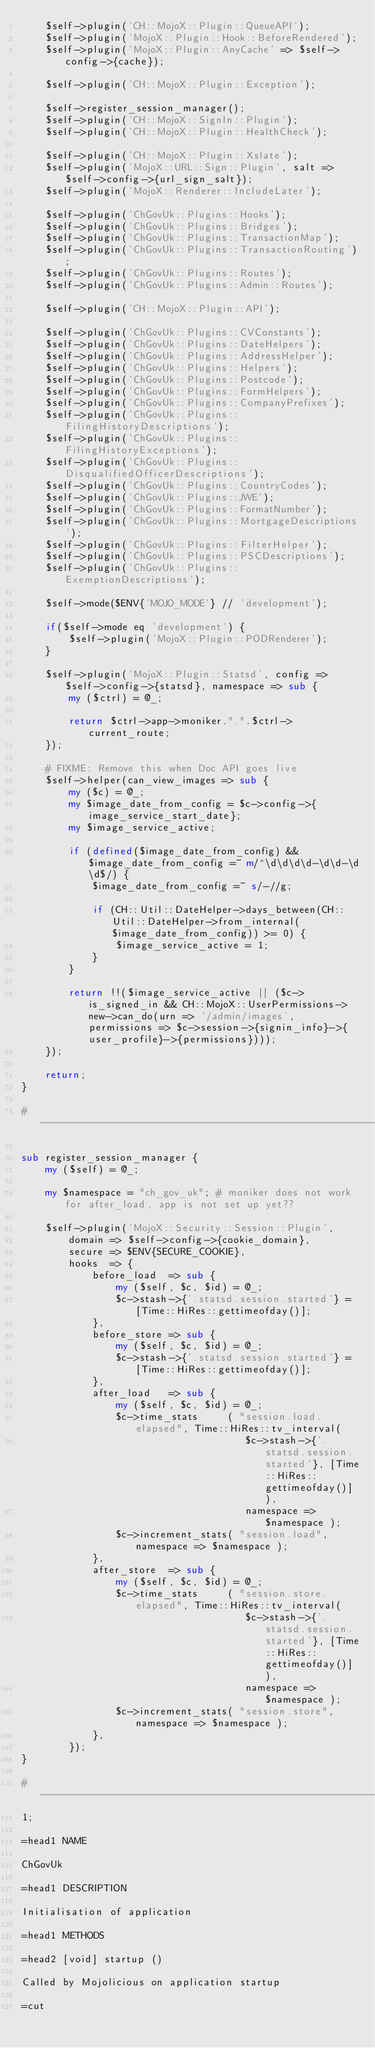<code> <loc_0><loc_0><loc_500><loc_500><_Perl_>    $self->plugin('CH::MojoX::Plugin::QueueAPI');
    $self->plugin('MojoX::Plugin::Hook::BeforeRendered');
    $self->plugin('MojoX::Plugin::AnyCache' => $self->config->{cache});

    $self->plugin('CH::MojoX::Plugin::Exception');

    $self->register_session_manager();
    $self->plugin('CH::MojoX::SignIn::Plugin');
    $self->plugin('CH::MojoX::Plugin::HealthCheck');

    $self->plugin('CH::MojoX::Plugin::Xslate');
    $self->plugin('MojoX::URL::Sign::Plugin', salt => $self->config->{url_sign_salt});
    $self->plugin('MojoX::Renderer::IncludeLater');

    $self->plugin('ChGovUk::Plugins::Hooks');
    $self->plugin('ChGovUk::Plugins::Bridges');
    $self->plugin('ChGovUk::Plugins::TransactionMap');
    $self->plugin('ChGovUk::Plugins::TransactionRouting');
    $self->plugin('ChGovUk::Plugins::Routes');
    $self->plugin('ChGovUk::Plugins::Admin::Routes');

    $self->plugin('CH::MojoX::Plugin::API');

    $self->plugin('ChGovUk::Plugins::CVConstants');
    $self->plugin('ChGovUk::Plugins::DateHelpers');
    $self->plugin('ChGovUk::Plugins::AddressHelper');
    $self->plugin('ChGovUk::Plugins::Helpers');
    $self->plugin('ChGovUk::Plugins::Postcode');
    $self->plugin('ChGovUk::Plugins::FormHelpers');
    $self->plugin('ChGovUk::Plugins::CompanyPrefixes');
    $self->plugin('ChGovUk::Plugins::FilingHistoryDescriptions');
    $self->plugin('ChGovUk::Plugins::FilingHistoryExceptions');
    $self->plugin('ChGovUk::Plugins::DisqualifiedOfficerDescriptions');
    $self->plugin('ChGovUk::Plugins::CountryCodes');
    $self->plugin('ChGovUk::Plugins::JWE');
    $self->plugin('ChGovUk::Plugins::FormatNumber');
    $self->plugin('ChGovUk::Plugins::MortgageDescriptions');
    $self->plugin('ChGovUk::Plugins::FilterHelper');
    $self->plugin('ChGovUk::Plugins::PSCDescriptions');
    $self->plugin('ChGovUk::Plugins::ExemptionDescriptions');

    $self->mode($ENV{'MOJO_MODE'} // 'development');

    if($self->mode eq 'development') {
        $self->plugin('MojoX::Plugin::PODRenderer');
    }

    $self->plugin('MojoX::Plugin::Statsd', config => $self->config->{statsd}, namespace => sub {
        my ($ctrl) = @_;

        return $ctrl->app->moniker.".".$ctrl->current_route;
    });

    # FIXME: Remove this when Doc API goes live
    $self->helper(can_view_images => sub {
        my ($c) = @_;
        my $image_date_from_config = $c->config->{image_service_start_date};
        my $image_service_active;

        if (defined($image_date_from_config) && $image_date_from_config =~ m/^\d\d\d\d-\d\d-\d\d$/) {
            $image_date_from_config =~ s/-//g;

            if (CH::Util::DateHelper->days_between(CH::Util::DateHelper->from_internal($image_date_from_config)) >= 0) {
                $image_service_active = 1;
            }
        }

        return !!($image_service_active || ($c->is_signed_in && CH::MojoX::UserPermissions->new->can_do(urn => '/admin/images', permissions => $c->session->{signin_info}->{user_profile}->{permissions})));
    });

    return;
}

#-------------------------------------------------------------------------------

sub register_session_manager {
    my ($self) = @_;

    my $namespace = "ch_gov_uk"; # moniker does not work for after_load, app is not set up yet??

    $self->plugin('MojoX::Security::Session::Plugin',
        domain => $self->config->{cookie_domain},
        secure => $ENV{SECURE_COOKIE},
        hooks  => {
            before_load  => sub {
                my ($self, $c, $id) = @_;
                $c->stash->{'.statsd.session.started'} = [Time::HiRes::gettimeofday()];
            },
            before_store => sub {
                my ($self, $c, $id) = @_;
                $c->stash->{'.statsd.session.started'} = [Time::HiRes::gettimeofday()];
            },
            after_load   => sub {
                my ($self, $c, $id) = @_;
                $c->time_stats     ( "session.load.elapsed", Time::HiRes::tv_interval(
                                      $c->stash->{'.statsd.session.started'}, [Time::HiRes::gettimeofday()] ),
                                      namespace =>  $namespace );
                $c->increment_stats( "session.load", namespace => $namespace );
            },
            after_store  => sub {
                my ($self, $c, $id) = @_;
                $c->time_stats     ( "session.store.elapsed", Time::HiRes::tv_interval(
                                      $c->stash->{'.statsd.session.started'}, [Time::HiRes::gettimeofday()] ),
                                      namespace => $namespace );
                $c->increment_stats( "session.store", namespace => $namespace );
            },
        });
}

#-------------------------------------------------------------------------------
1;

=head1 NAME

ChGovUk

=head1 DESCRIPTION

Initialisation of application

=head1 METHODS

=head2 [void] startup ()

Called by Mojolicious on application startup

=cut
</code> 